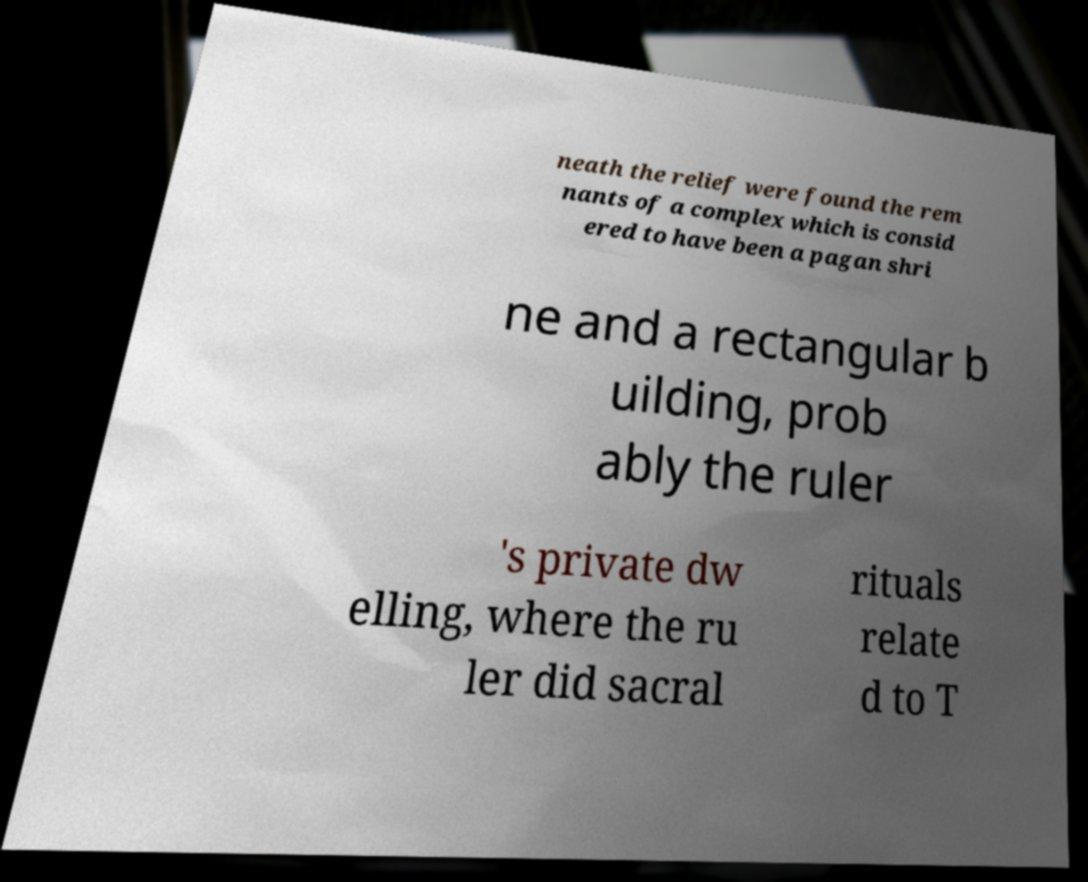Can you accurately transcribe the text from the provided image for me? neath the relief were found the rem nants of a complex which is consid ered to have been a pagan shri ne and a rectangular b uilding, prob ably the ruler 's private dw elling, where the ru ler did sacral rituals relate d to T 